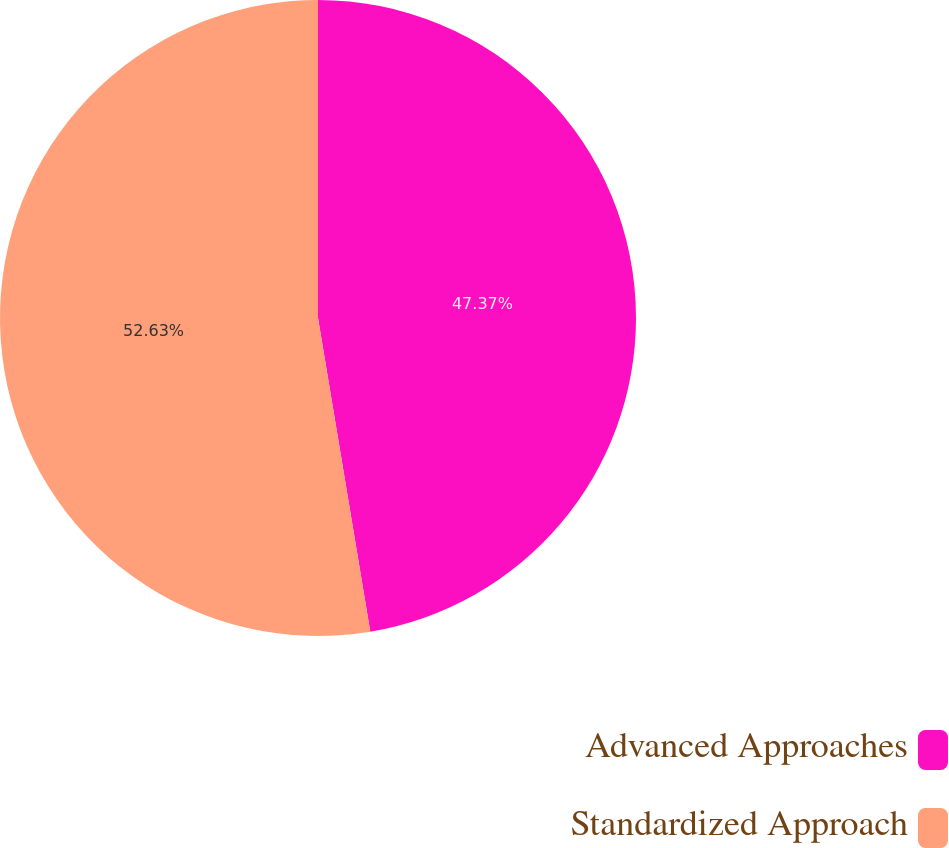Convert chart to OTSL. <chart><loc_0><loc_0><loc_500><loc_500><pie_chart><fcel>Advanced Approaches<fcel>Standardized Approach<nl><fcel>47.37%<fcel>52.63%<nl></chart> 